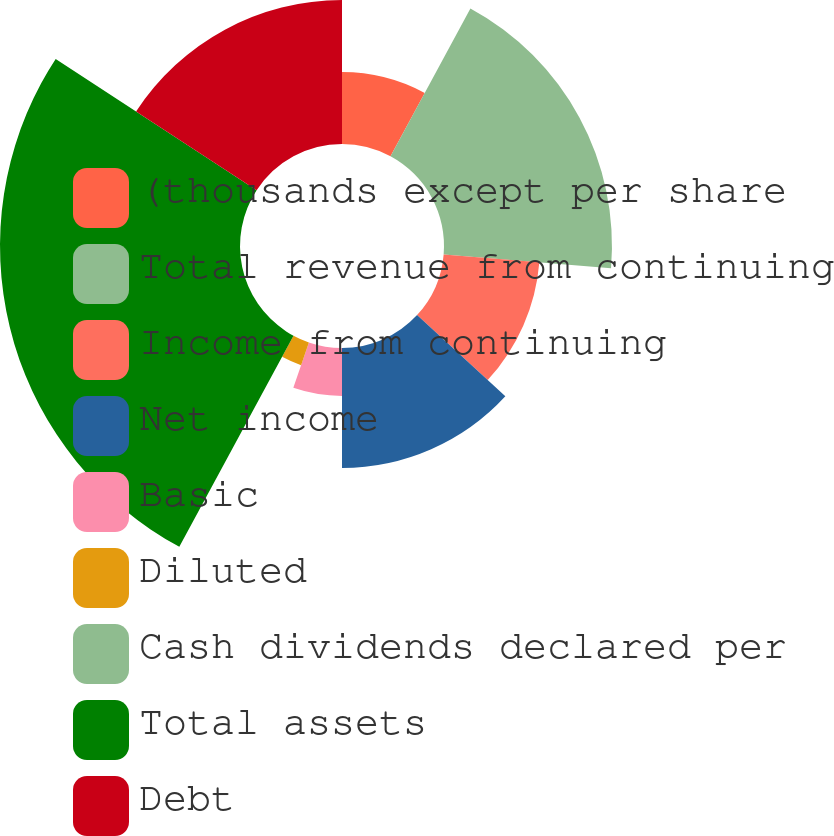Convert chart. <chart><loc_0><loc_0><loc_500><loc_500><pie_chart><fcel>(thousands except per share<fcel>Total revenue from continuing<fcel>Income from continuing<fcel>Net income<fcel>Basic<fcel>Diluted<fcel>Cash dividends declared per<fcel>Total assets<fcel>Debt<nl><fcel>7.89%<fcel>18.42%<fcel>10.53%<fcel>13.16%<fcel>5.26%<fcel>2.63%<fcel>0.0%<fcel>26.32%<fcel>15.79%<nl></chart> 